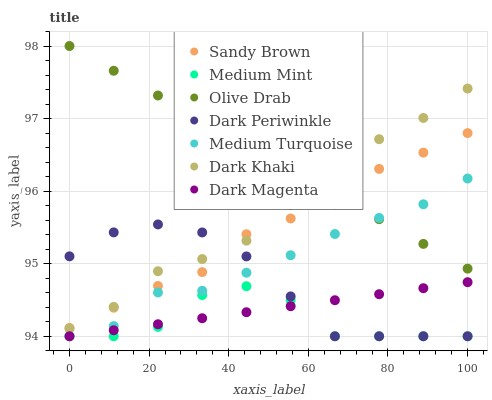Does Medium Mint have the minimum area under the curve?
Answer yes or no. Yes. Does Olive Drab have the maximum area under the curve?
Answer yes or no. Yes. Does Dark Magenta have the minimum area under the curve?
Answer yes or no. No. Does Dark Magenta have the maximum area under the curve?
Answer yes or no. No. Is Olive Drab the smoothest?
Answer yes or no. Yes. Is Medium Mint the roughest?
Answer yes or no. Yes. Is Dark Magenta the smoothest?
Answer yes or no. No. Is Dark Magenta the roughest?
Answer yes or no. No. Does Medium Mint have the lowest value?
Answer yes or no. Yes. Does Dark Khaki have the lowest value?
Answer yes or no. No. Does Olive Drab have the highest value?
Answer yes or no. Yes. Does Dark Magenta have the highest value?
Answer yes or no. No. Is Medium Mint less than Olive Drab?
Answer yes or no. Yes. Is Olive Drab greater than Dark Periwinkle?
Answer yes or no. Yes. Does Dark Khaki intersect Dark Periwinkle?
Answer yes or no. Yes. Is Dark Khaki less than Dark Periwinkle?
Answer yes or no. No. Is Dark Khaki greater than Dark Periwinkle?
Answer yes or no. No. Does Medium Mint intersect Olive Drab?
Answer yes or no. No. 